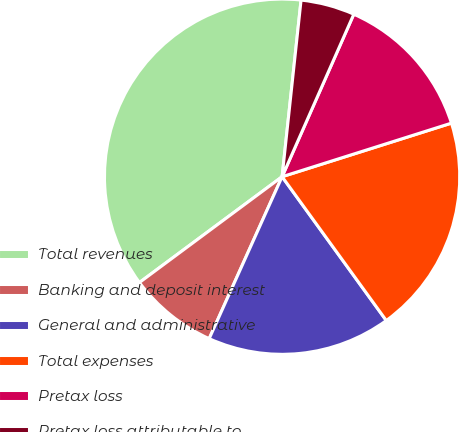<chart> <loc_0><loc_0><loc_500><loc_500><pie_chart><fcel>Total revenues<fcel>Banking and deposit interest<fcel>General and administrative<fcel>Total expenses<fcel>Pretax loss<fcel>Pretax loss attributable to<nl><fcel>36.86%<fcel>8.11%<fcel>16.71%<fcel>19.9%<fcel>13.51%<fcel>4.91%<nl></chart> 